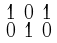<formula> <loc_0><loc_0><loc_500><loc_500>\begin{smallmatrix} 1 & 0 & 1 \\ 0 & 1 & 0 \end{smallmatrix}</formula> 